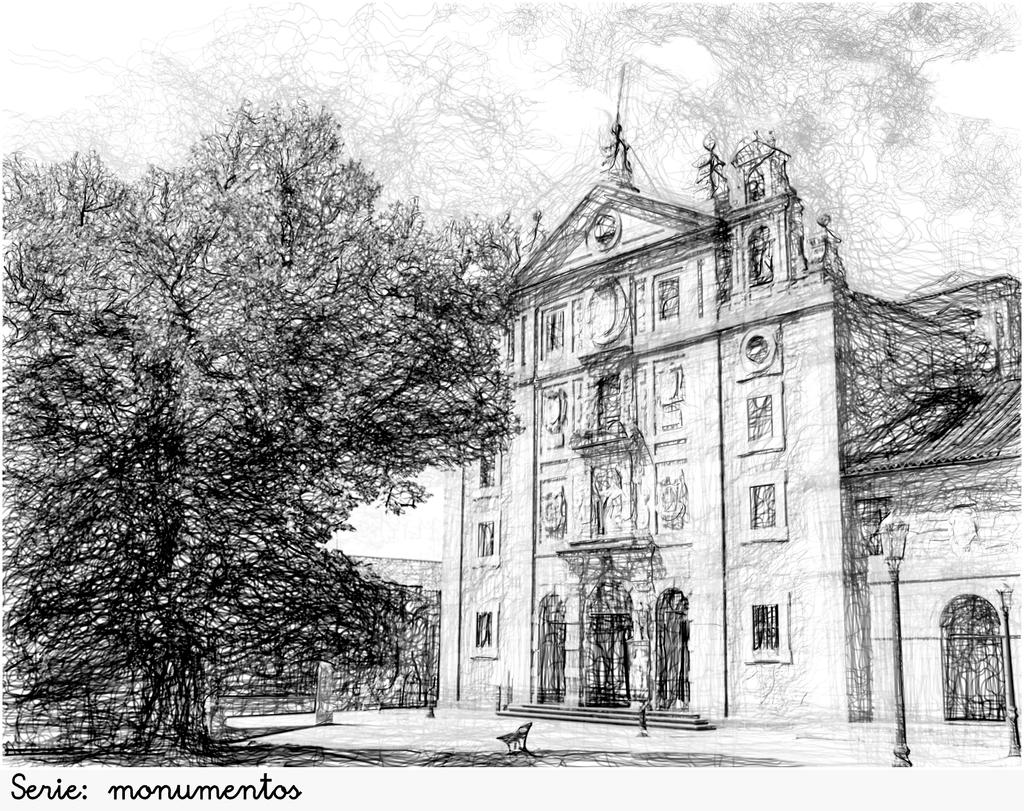What type of natural elements are present in the image? There are trees in the image. What type of man-made structures are present in the image? There are buildings in the image. What type of vertical structures are present in the image? There are poles in the image. What type of artistic creation is present in the image? There is a drawing in the image. Where are the toys located in the image? There are no toys present in the image. What type of cooking appliance is visible in the image? There is no stove present in the image. 